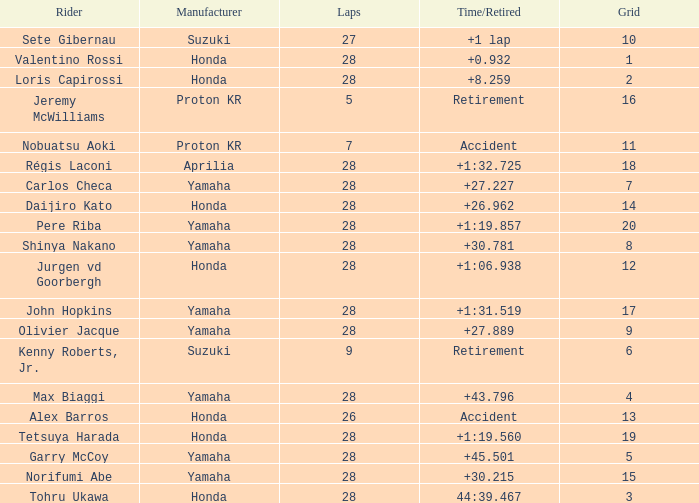How many laps did pere riba ride? 28.0. 